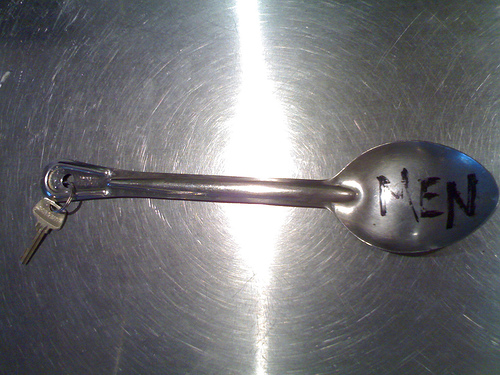<image>
Is the spoon on the vessel? Yes. Looking at the image, I can see the spoon is positioned on top of the vessel, with the vessel providing support. 